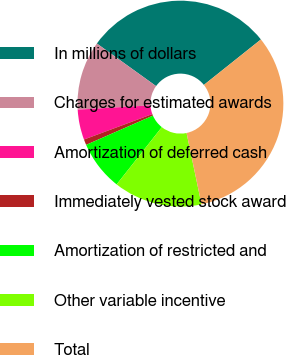Convert chart. <chart><loc_0><loc_0><loc_500><loc_500><pie_chart><fcel>In millions of dollars<fcel>Charges for estimated awards<fcel>Amortization of deferred cash<fcel>Immediately vested stock award<fcel>Amortization of restricted and<fcel>Other variable incentive<fcel>Total<nl><fcel>29.37%<fcel>10.86%<fcel>4.74%<fcel>0.89%<fcel>7.8%<fcel>13.92%<fcel>32.43%<nl></chart> 